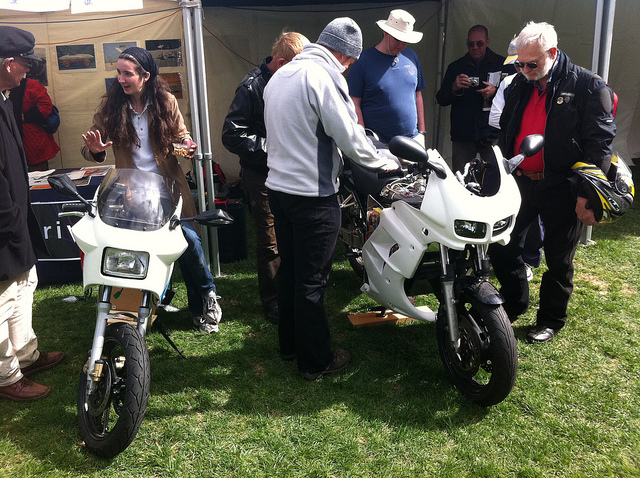Read and extract the text from this image. ri 